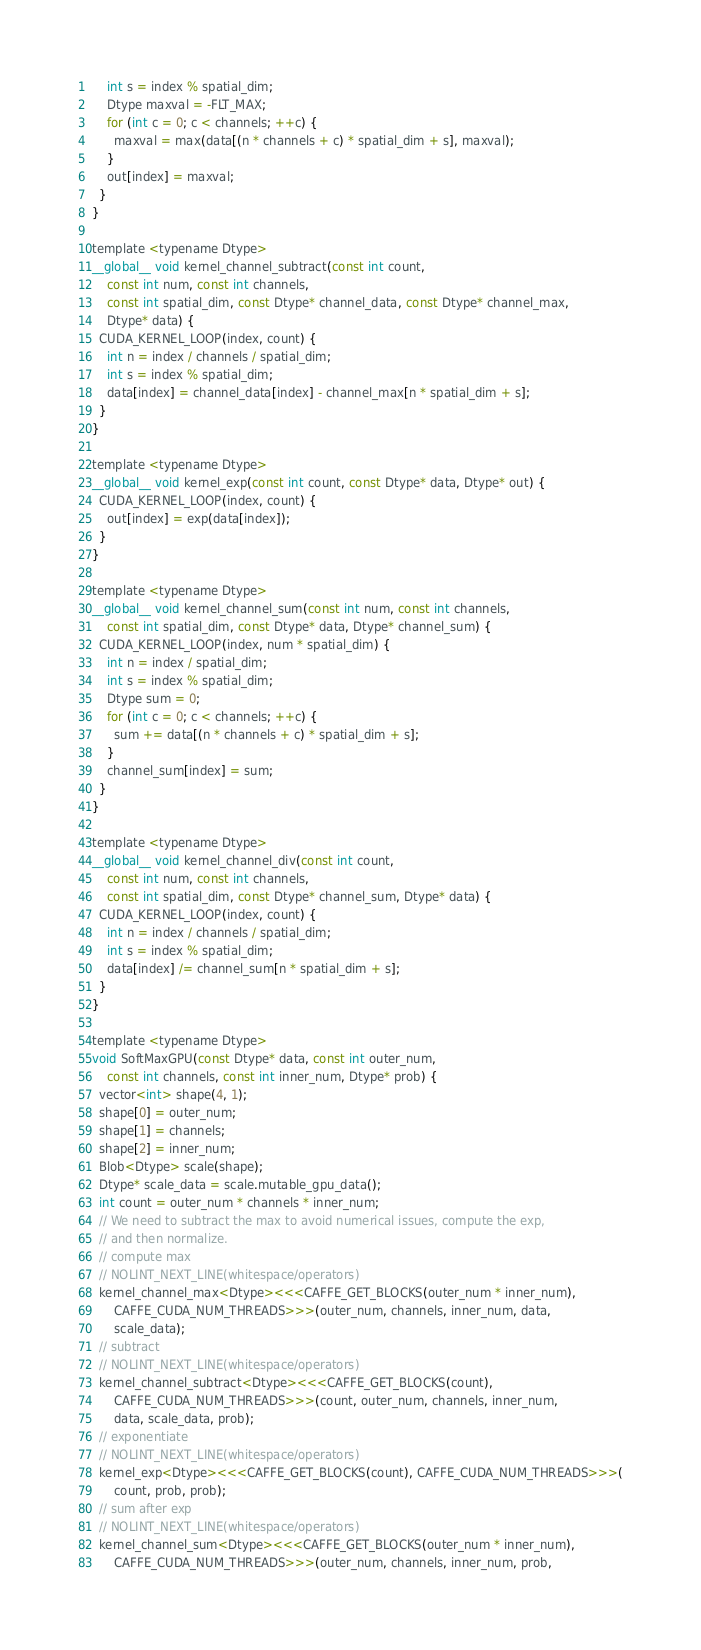Convert code to text. <code><loc_0><loc_0><loc_500><loc_500><_Cuda_>    int s = index % spatial_dim;
    Dtype maxval = -FLT_MAX;
    for (int c = 0; c < channels; ++c) {
      maxval = max(data[(n * channels + c) * spatial_dim + s], maxval);
    }
    out[index] = maxval;
  }
}

template <typename Dtype>
__global__ void kernel_channel_subtract(const int count,
    const int num, const int channels,
    const int spatial_dim, const Dtype* channel_data, const Dtype* channel_max,
    Dtype* data) {
  CUDA_KERNEL_LOOP(index, count) {
    int n = index / channels / spatial_dim;
    int s = index % spatial_dim;
    data[index] = channel_data[index] - channel_max[n * spatial_dim + s];
  }
}

template <typename Dtype>
__global__ void kernel_exp(const int count, const Dtype* data, Dtype* out) {
  CUDA_KERNEL_LOOP(index, count) {
    out[index] = exp(data[index]);
  }
}

template <typename Dtype>
__global__ void kernel_channel_sum(const int num, const int channels,
    const int spatial_dim, const Dtype* data, Dtype* channel_sum) {
  CUDA_KERNEL_LOOP(index, num * spatial_dim) {
    int n = index / spatial_dim;
    int s = index % spatial_dim;
    Dtype sum = 0;
    for (int c = 0; c < channels; ++c) {
      sum += data[(n * channels + c) * spatial_dim + s];
    }
    channel_sum[index] = sum;
  }
}

template <typename Dtype>
__global__ void kernel_channel_div(const int count,
    const int num, const int channels,
    const int spatial_dim, const Dtype* channel_sum, Dtype* data) {
  CUDA_KERNEL_LOOP(index, count) {
    int n = index / channels / spatial_dim;
    int s = index % spatial_dim;
    data[index] /= channel_sum[n * spatial_dim + s];
  }
}

template <typename Dtype>
void SoftMaxGPU(const Dtype* data, const int outer_num,
    const int channels, const int inner_num, Dtype* prob) {
  vector<int> shape(4, 1);
  shape[0] = outer_num;
  shape[1] = channels;
  shape[2] = inner_num;
  Blob<Dtype> scale(shape);
  Dtype* scale_data = scale.mutable_gpu_data();
  int count = outer_num * channels * inner_num;
  // We need to subtract the max to avoid numerical issues, compute the exp,
  // and then normalize.
  // compute max
  // NOLINT_NEXT_LINE(whitespace/operators)
  kernel_channel_max<Dtype><<<CAFFE_GET_BLOCKS(outer_num * inner_num),
      CAFFE_CUDA_NUM_THREADS>>>(outer_num, channels, inner_num, data,
      scale_data);
  // subtract
  // NOLINT_NEXT_LINE(whitespace/operators)
  kernel_channel_subtract<Dtype><<<CAFFE_GET_BLOCKS(count),
      CAFFE_CUDA_NUM_THREADS>>>(count, outer_num, channels, inner_num,
      data, scale_data, prob);
  // exponentiate
  // NOLINT_NEXT_LINE(whitespace/operators)
  kernel_exp<Dtype><<<CAFFE_GET_BLOCKS(count), CAFFE_CUDA_NUM_THREADS>>>(
      count, prob, prob);
  // sum after exp
  // NOLINT_NEXT_LINE(whitespace/operators)
  kernel_channel_sum<Dtype><<<CAFFE_GET_BLOCKS(outer_num * inner_num),
      CAFFE_CUDA_NUM_THREADS>>>(outer_num, channels, inner_num, prob,</code> 